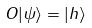<formula> <loc_0><loc_0><loc_500><loc_500>O | \psi \rangle = | h \rangle</formula> 